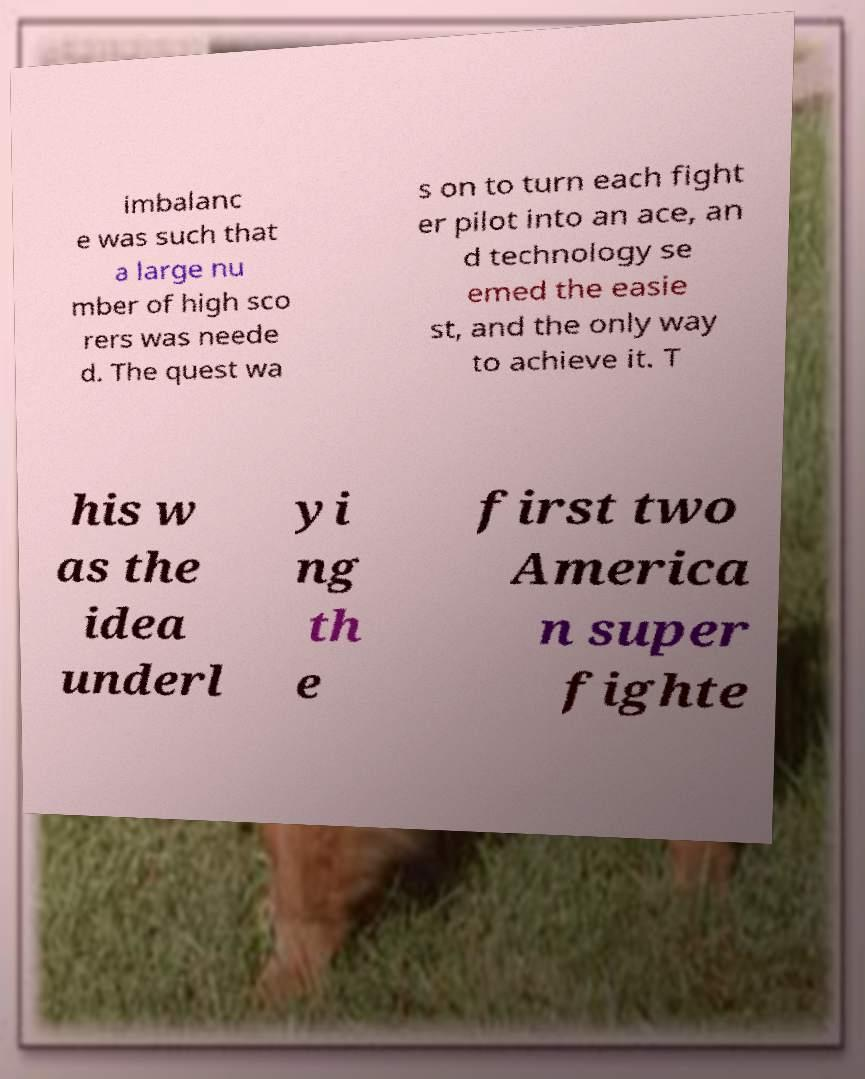Can you accurately transcribe the text from the provided image for me? imbalanc e was such that a large nu mber of high sco rers was neede d. The quest wa s on to turn each fight er pilot into an ace, an d technology se emed the easie st, and the only way to achieve it. T his w as the idea underl yi ng th e first two America n super fighte 